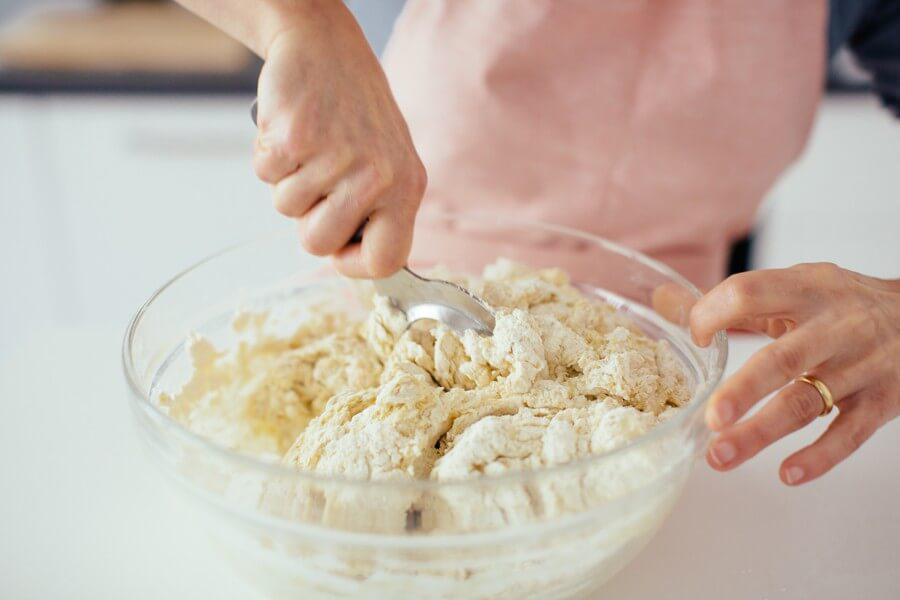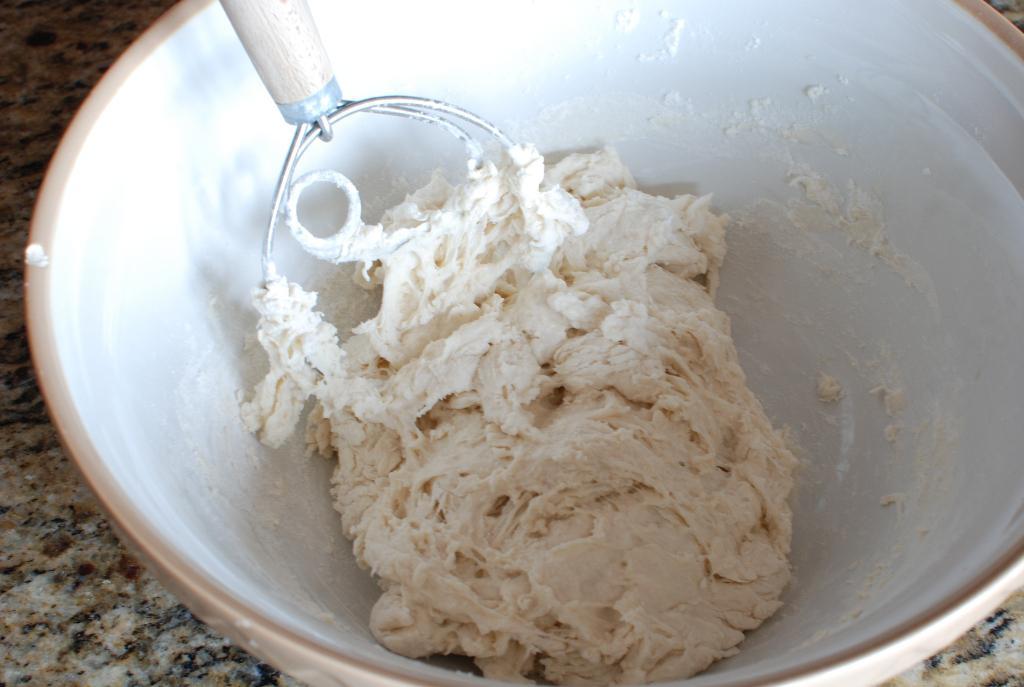The first image is the image on the left, the second image is the image on the right. For the images shown, is this caption "In exactly one of the images a person is mixing dough with a utensil." true? Answer yes or no. Yes. The first image is the image on the left, the second image is the image on the right. Assess this claim about the two images: "Each image shows a utensil in a bowl of food mixture, and one image shows one hand stirring with the utensil as the other hand holds the edge of the bowl.". Correct or not? Answer yes or no. Yes. 